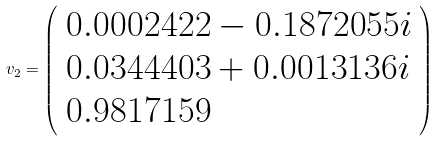<formula> <loc_0><loc_0><loc_500><loc_500>v _ { 2 } = { \left ( \begin{array} { l } { 0 . 0 0 0 2 4 2 2 - 0 . 1 8 7 2 0 5 5 i } \\ { 0 . 0 3 4 4 4 0 3 + 0 . 0 0 1 3 1 3 6 i } \\ { 0 . 9 8 1 7 1 5 9 } \end{array} \right ) }</formula> 